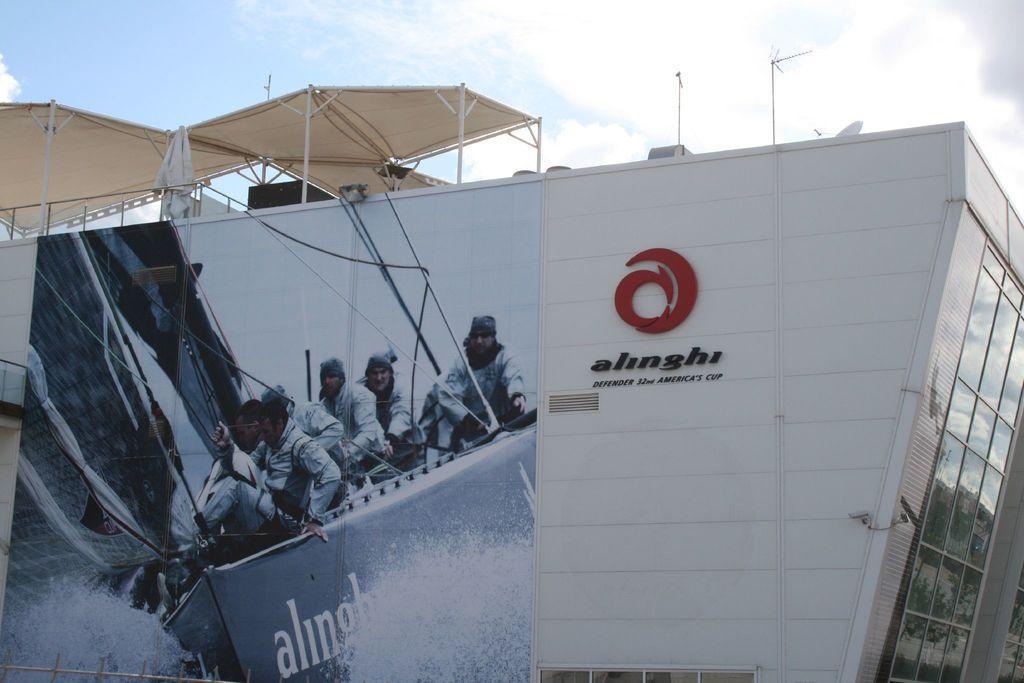Can you describe this image briefly? In this image there is a building with some hoarding on it and some tents on the roof. 